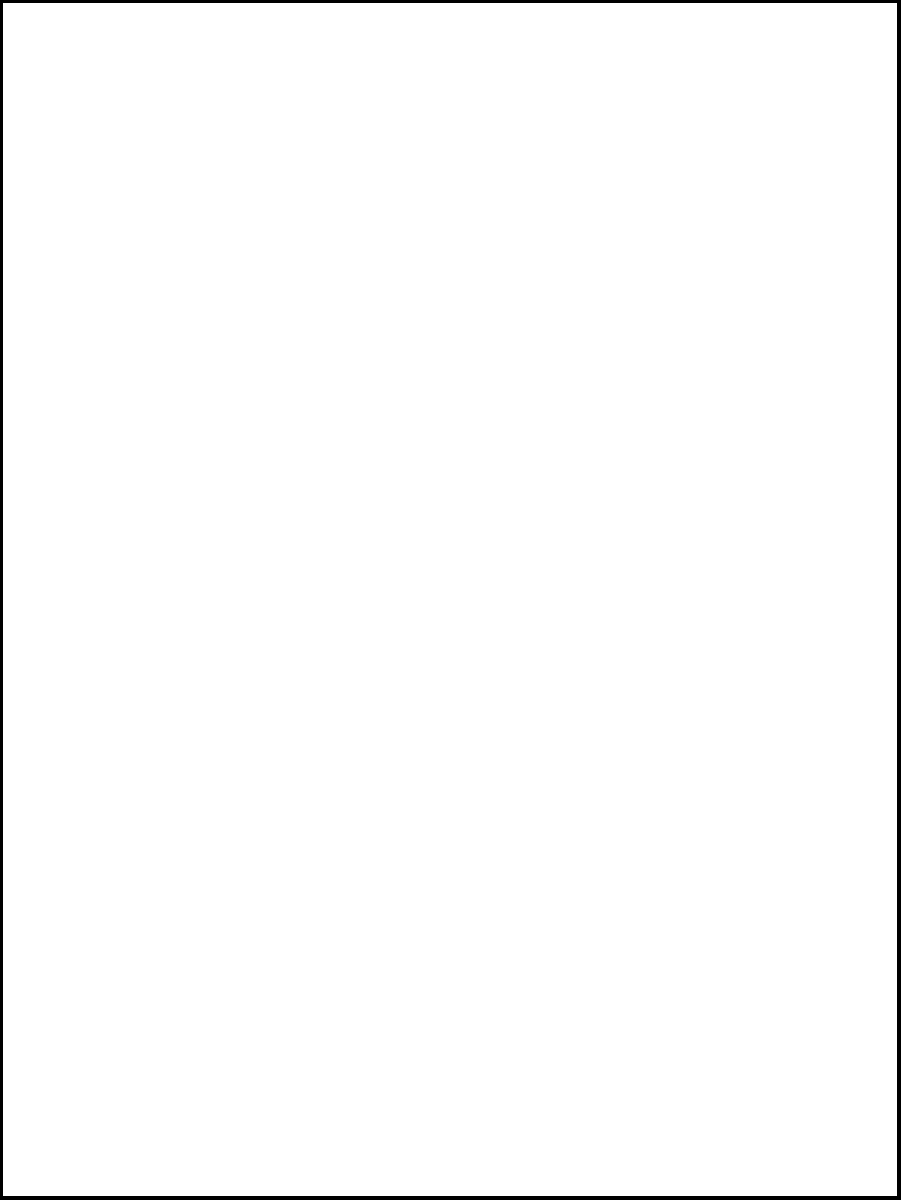Comparing the façades of two similar Berkeley landmarks, which pair of points corresponds to each other under a congruence transformation that maps the left façade to the right façade? To determine the corresponding points under a congruence transformation, we need to analyze the geometric properties of both façades:

1. Both façades are rectangles with the same proportions and window arrangements.
2. A congruence transformation preserves shape, size, and angle measures.
3. The transformation mapping the left façade to the right façade is a translation to the right.

Let's examine each point:
- Point A is the bottom-left corner of the left façade.
- Point E is the bottom-left corner of the right façade.

Since the transformation is a translation to the right, the bottom-left corner of the left façade (A) corresponds to the bottom-left corner of the right façade (E).

Similarly:
- B corresponds to F (bottom-right corners)
- C corresponds to G (top-right corners)
- D corresponds to H (top-left corners)

Therefore, the pair of points that correspond to each other under the congruence transformation is A and E.
Answer: A and E 